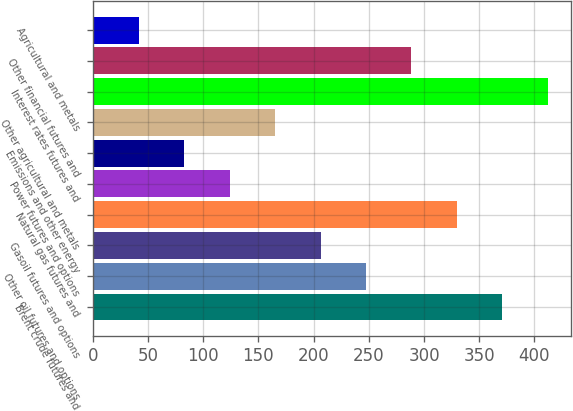<chart> <loc_0><loc_0><loc_500><loc_500><bar_chart><fcel>Brent crude futures and<fcel>Other oil futures and options<fcel>Gasoil futures and options<fcel>Natural gas futures and<fcel>Power futures and options<fcel>Emissions and other energy<fcel>Other agricultural and metals<fcel>Interest rates futures and<fcel>Other financial futures and<fcel>Agricultural and metals<nl><fcel>370.89<fcel>247.44<fcel>206.29<fcel>329.74<fcel>123.99<fcel>82.84<fcel>165.14<fcel>412.04<fcel>288.59<fcel>41.69<nl></chart> 